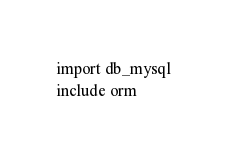<code> <loc_0><loc_0><loc_500><loc_500><_Nim_>import db_mysql
include orm
</code> 